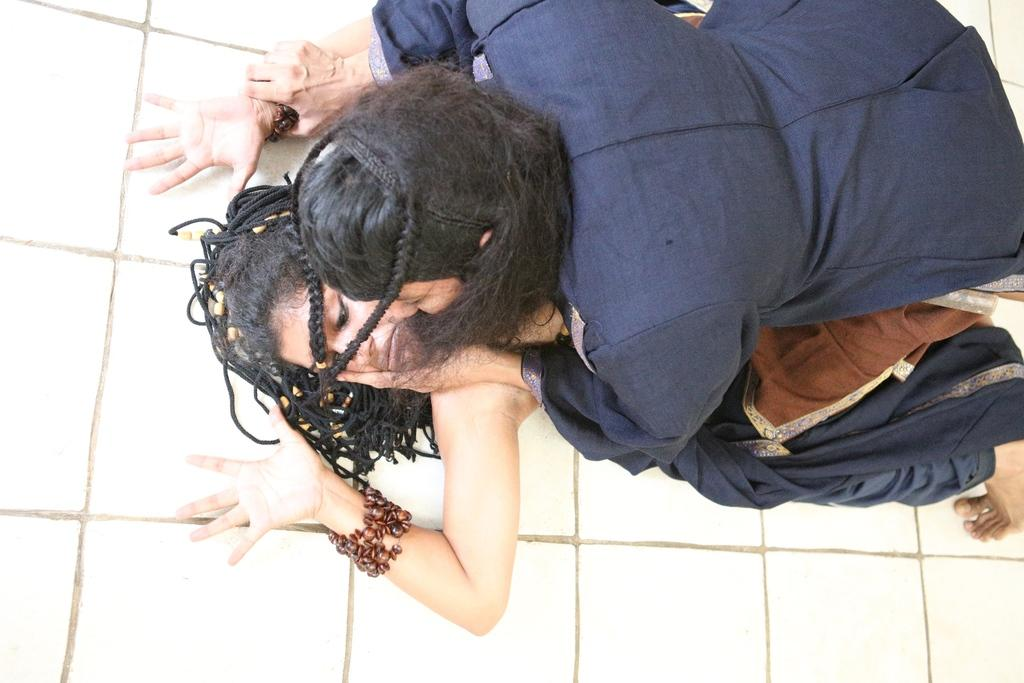How many people are present in the image? There are two persons in the image. What can be seen in the background of the image? There is a white wall in the background of the image. What type of pan is hanging on the wall in the image? There is no pan present in the image; it only features two persons and a white wall in the background. 